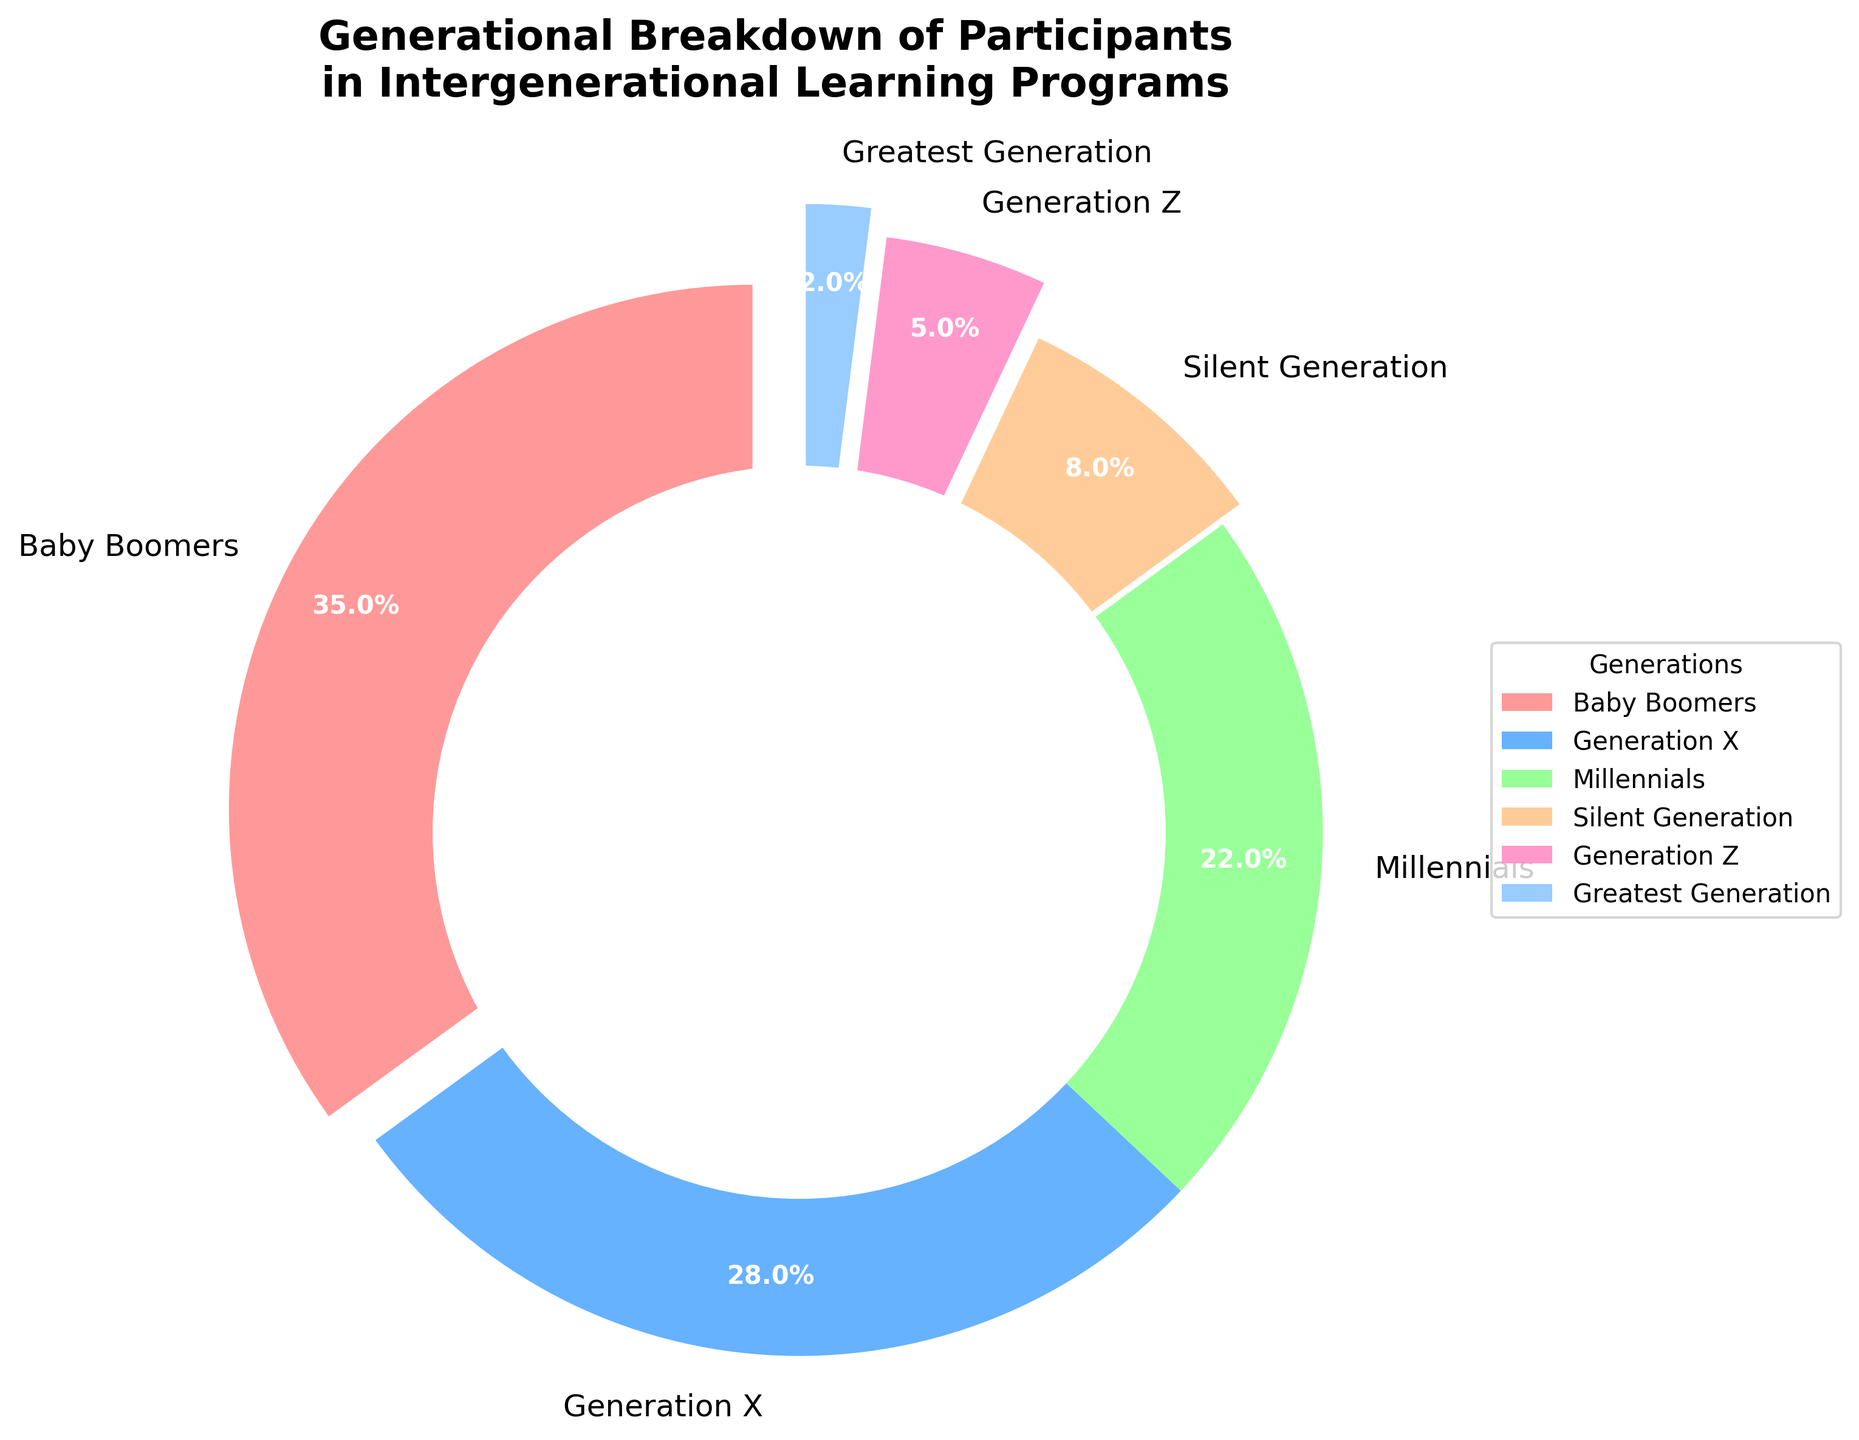What percentage of participants come from Baby Boomers and Generation X combined? Baby Boomers have 35% and Generation X has 28%. The combined percentage is 35% + 28%.
Answer: 63% Which generation has the lowest percentage of participants? From the pie chart, the Greatest Generation has the smallest segment. It is labeled as 2%.
Answer: Greatest Generation How many generations have a percentage of 20% or more? From the chart, we see Baby Boomers (35%), Generation X (28%), and Millennials (22%) each have more than 20%. This counts as 3 generations.
Answer: 3 Which generation is represented by the largest segment of the pie chart? The largest segment is labeled 35%, which corresponds to the Baby Boomers.
Answer: Baby Boomers What is the difference in percentage between the Silent Generation and Generation Z? The Silent Generation has 8% and Generation Z has 5%. The difference is 8% - 5%.
Answer: 3% What color is used for the Millennials segment? From the pie chart, the segment for Millennials (22%) is displayed in green.
Answer: Green Compare the size of the segments for the Silent Generation and the Greatest Generation. Which is larger and by how much? The Silent Generation is 8% and the Greatest Generation is 2%. The Silent Generation is larger by 8% - 2%.
Answer: Silent Generation by 6% How does the combined percentage of Millennials and Generation Z compare to Generation X? Millennials are 22% and Generation Z is 5%. Combined, they are 22% + 5% = 27%. Generation X is 28%.
Answer: 1% less Which generation shows an exploding segment effect the most in the chart? The segment for the Greatest Generation (2%) is visually more exploded compared to others.
Answer: Greatest Generation What is the sum of the percentages of generations younger than Generation X? Millennials (22%), Generation Z (5%), and combined they are 22% + 5%.
Answer: 27% 